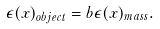Convert formula to latex. <formula><loc_0><loc_0><loc_500><loc_500>\epsilon ( x ) _ { o b j e c t } = b \epsilon ( x ) _ { m a s s } .</formula> 